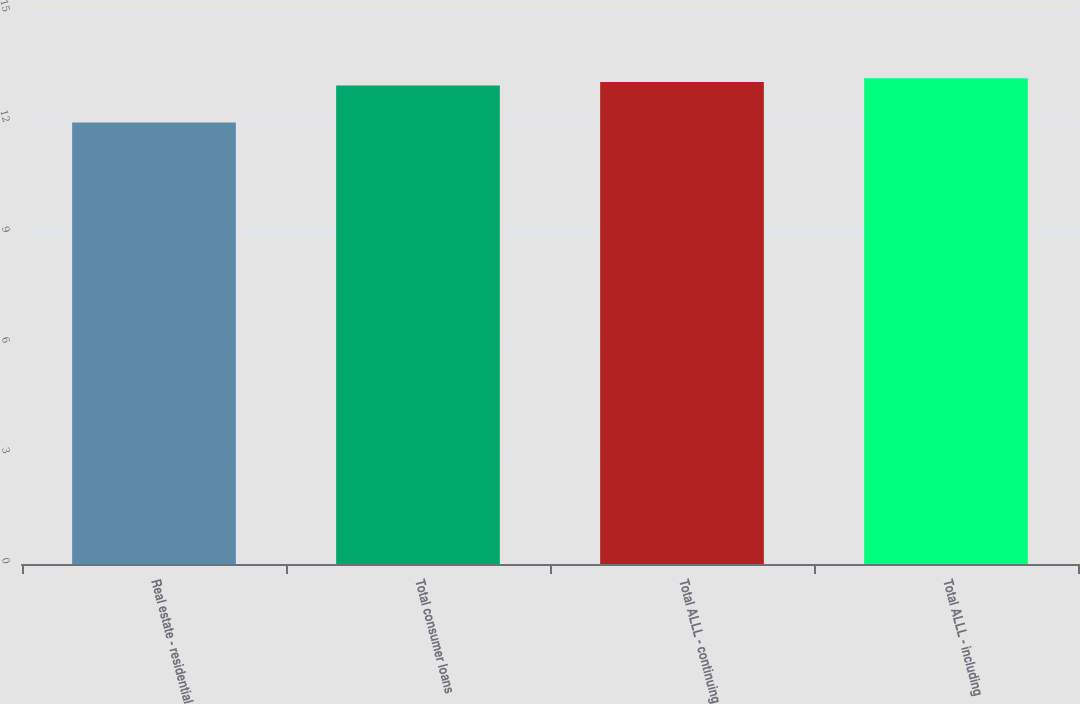Convert chart to OTSL. <chart><loc_0><loc_0><loc_500><loc_500><bar_chart><fcel>Real estate - residential<fcel>Total consumer loans<fcel>Total ALLL - continuing<fcel>Total ALLL - including<nl><fcel>12<fcel>13<fcel>13.1<fcel>13.2<nl></chart> 